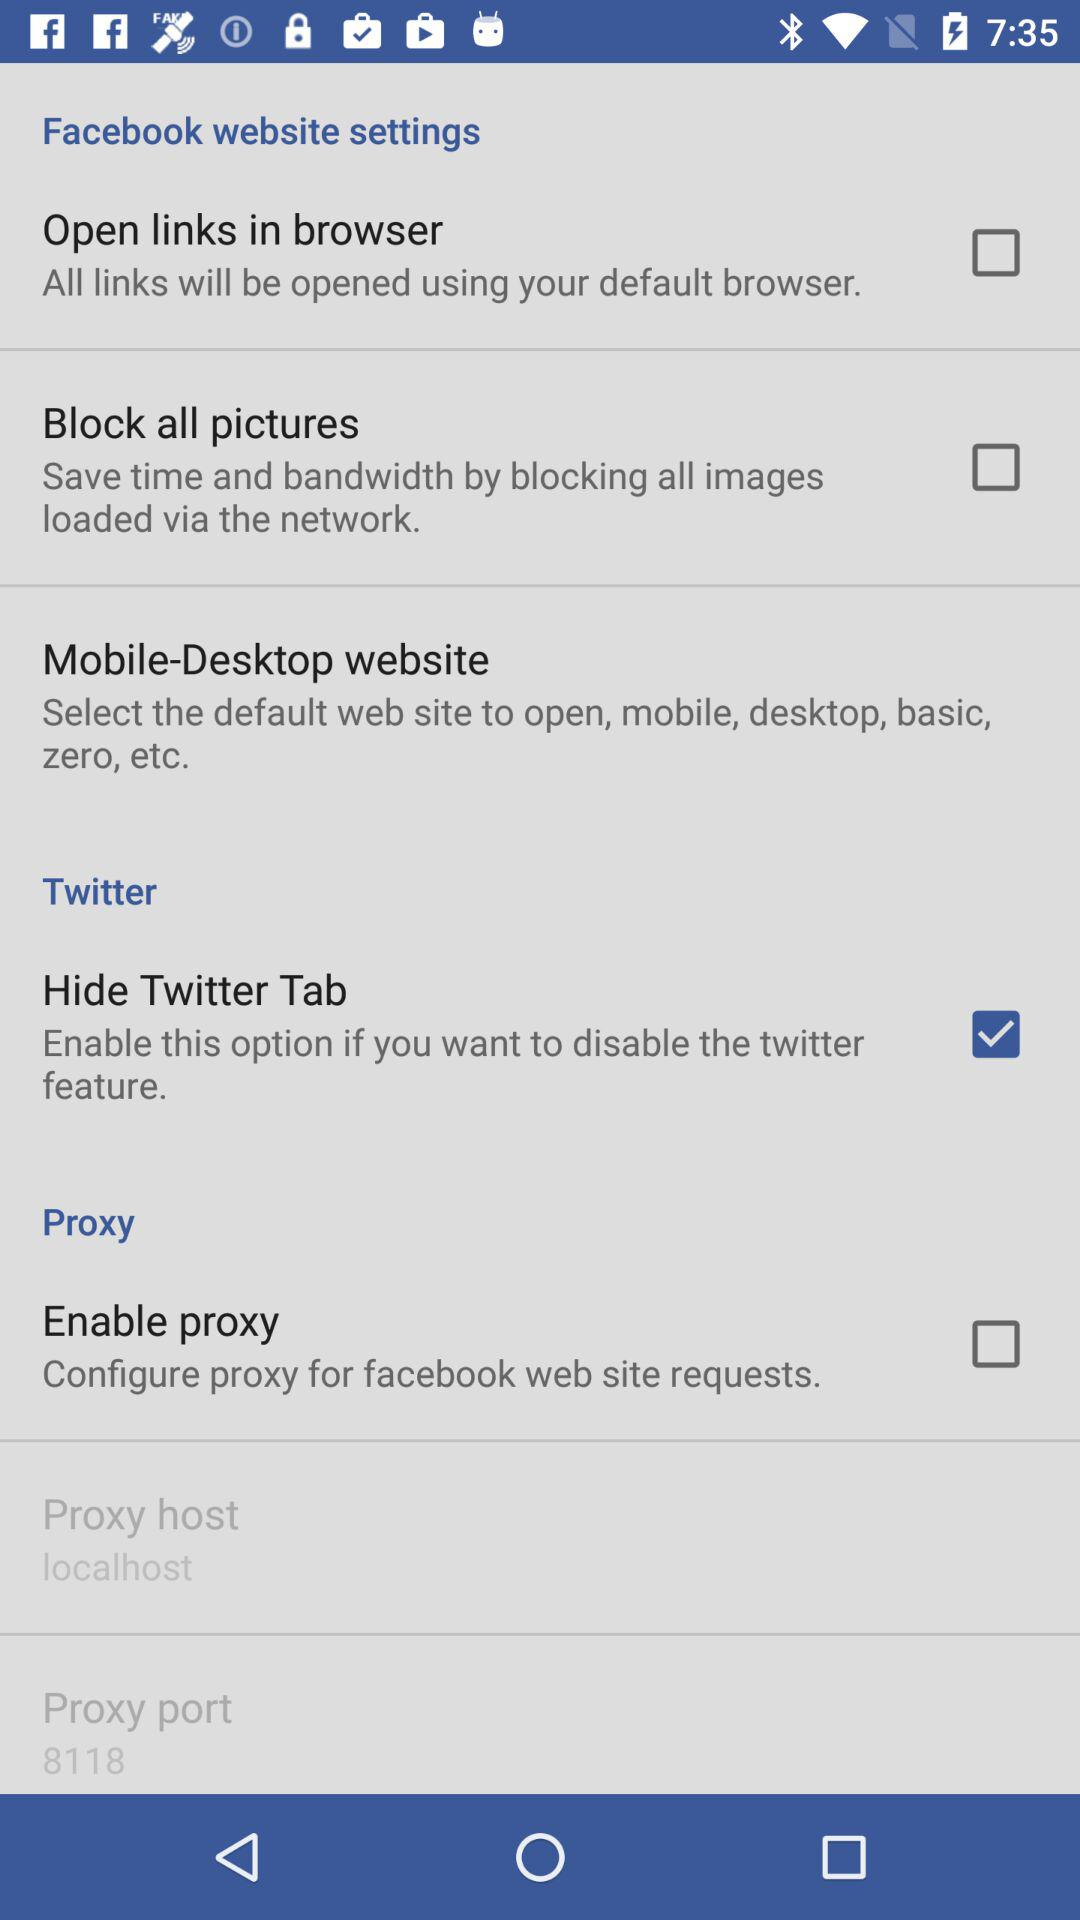What is the status of the "Hide Twitter Tab"? The status of the "Hide Twitter Tab" is "on". 